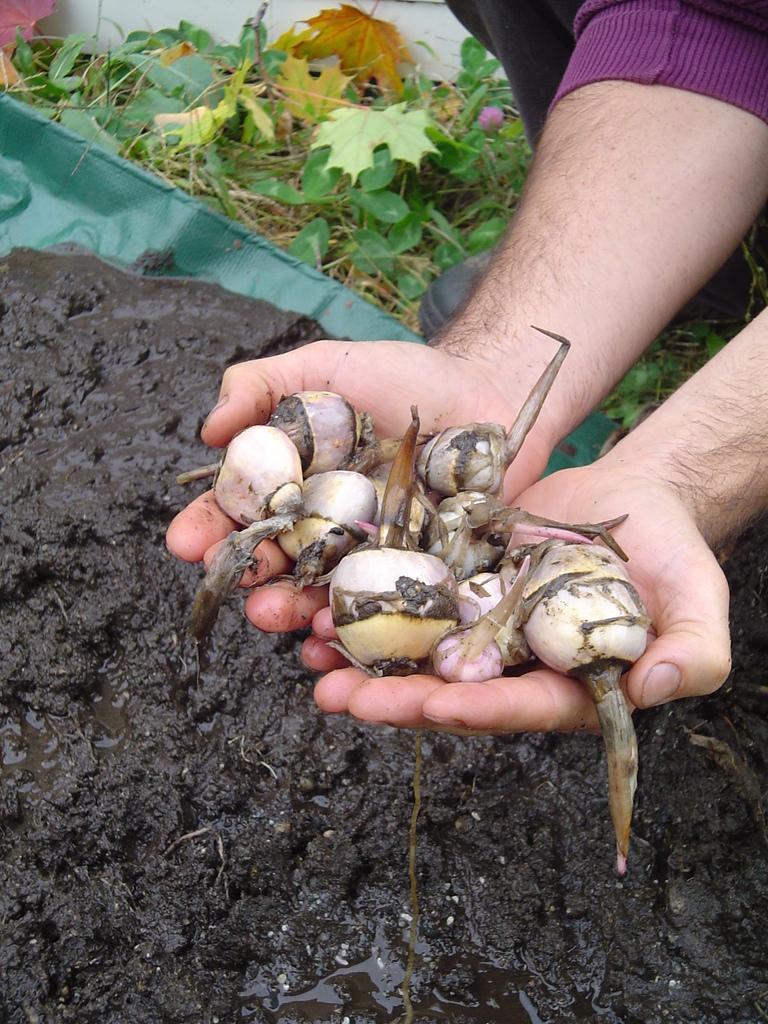Describe this image in one or two sentences. This image is taken outdoors. At the bottom of the image there is a soil on the ground. On the right side of the image a person is holding a few turnips in his hands. At the top of the image there is a ground with grass and a few leaves on it. 